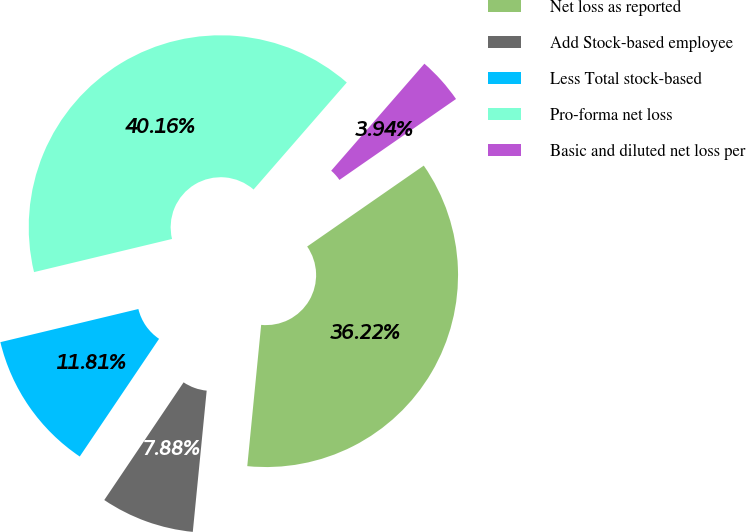<chart> <loc_0><loc_0><loc_500><loc_500><pie_chart><fcel>Net loss as reported<fcel>Add Stock-based employee<fcel>Less Total stock-based<fcel>Pro-forma net loss<fcel>Basic and diluted net loss per<nl><fcel>36.22%<fcel>7.88%<fcel>11.81%<fcel>40.16%<fcel>3.94%<nl></chart> 